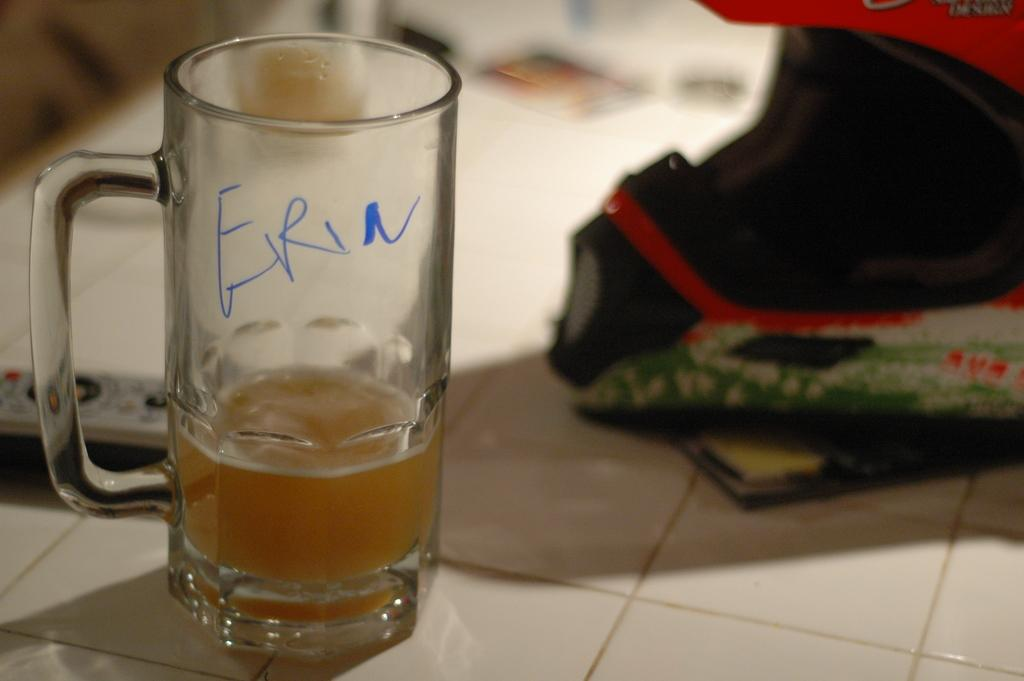What is in the glass that is visible in the image? There is a drink in the glass in the image. What other object can be seen in the image besides the glass? There is a helmet in the image. Where are the glass and helmet placed in the image? The glass and helmet are placed on a tiled floor in the image. What type of trains can be seen passing by in the image? There are no trains present in the image; it features a glass with a drink, a helmet, and a tiled floor. 